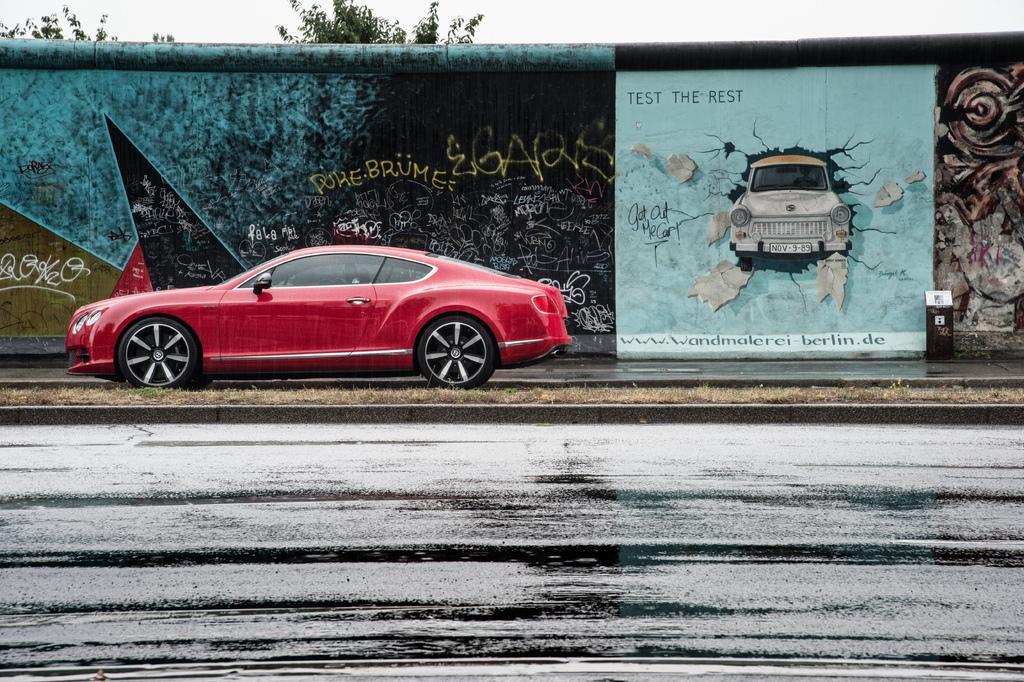Describe this image in one or two sentences. This image is taken outdoors. At the bottom of the image there is a road. In the middle of the image a car is parked on the road and there is a wall with a graffiti on it. At the top of the image there is a sky and there are two trees. 